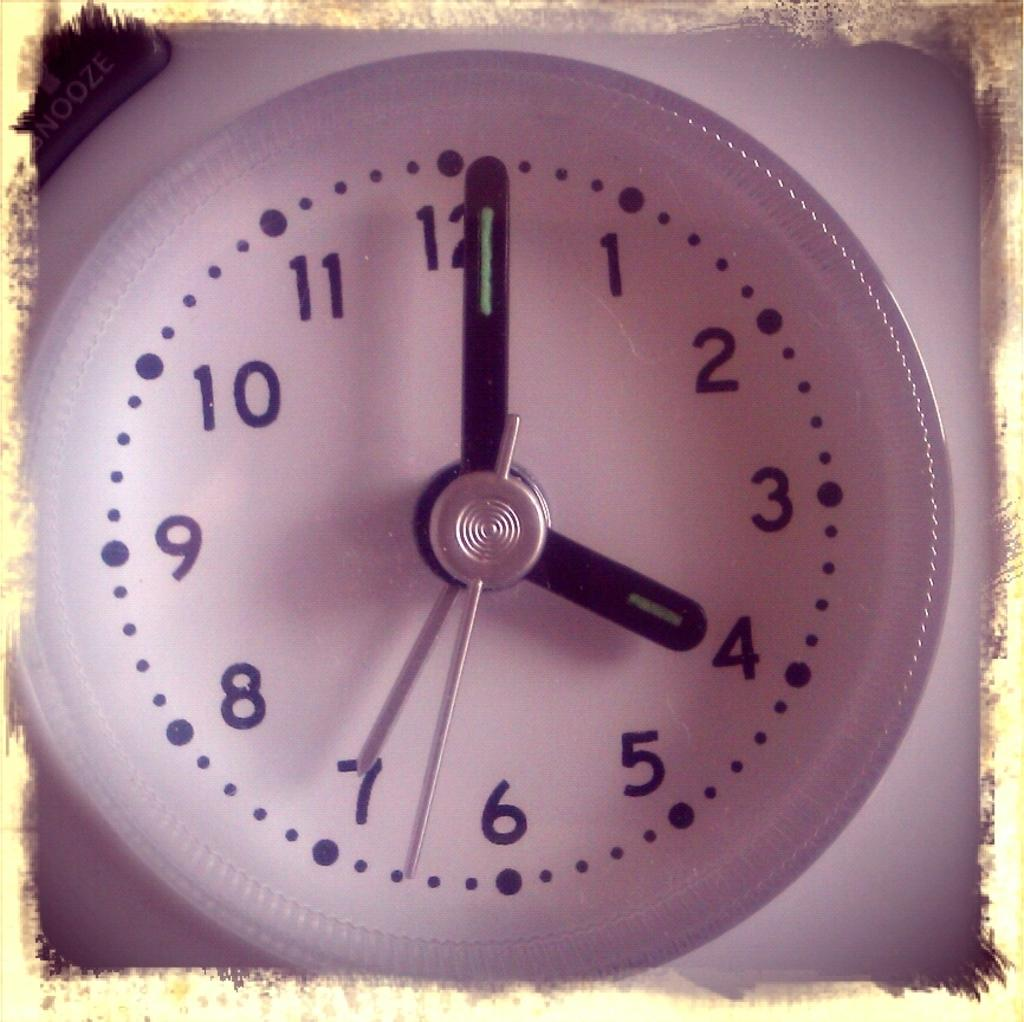<image>
Give a short and clear explanation of the subsequent image. A round white clock shows the time 4:01. 